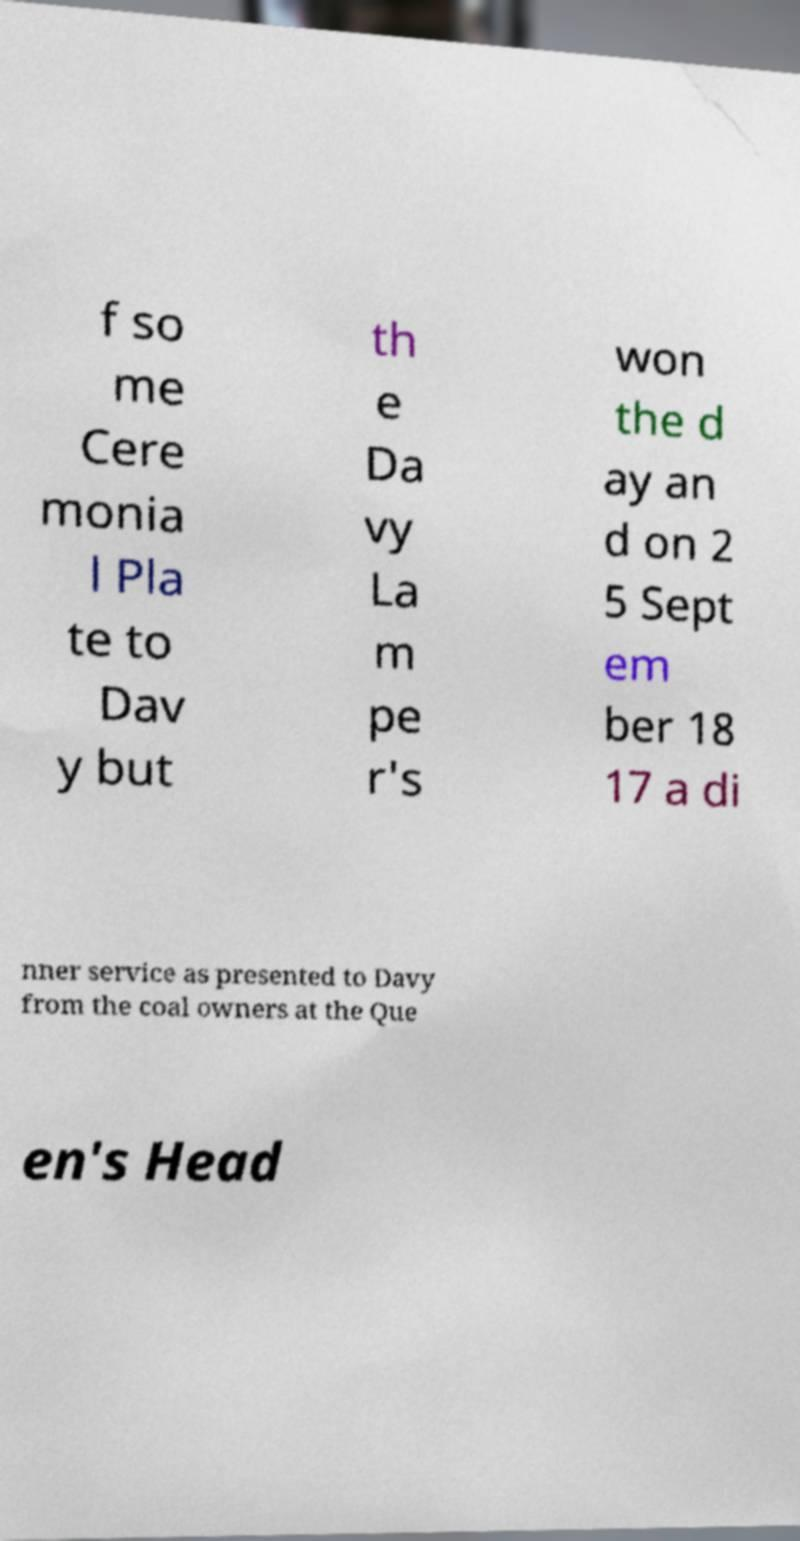Can you read and provide the text displayed in the image?This photo seems to have some interesting text. Can you extract and type it out for me? f so me Cere monia l Pla te to Dav y but th e Da vy La m pe r's won the d ay an d on 2 5 Sept em ber 18 17 a di nner service as presented to Davy from the coal owners at the Que en's Head 